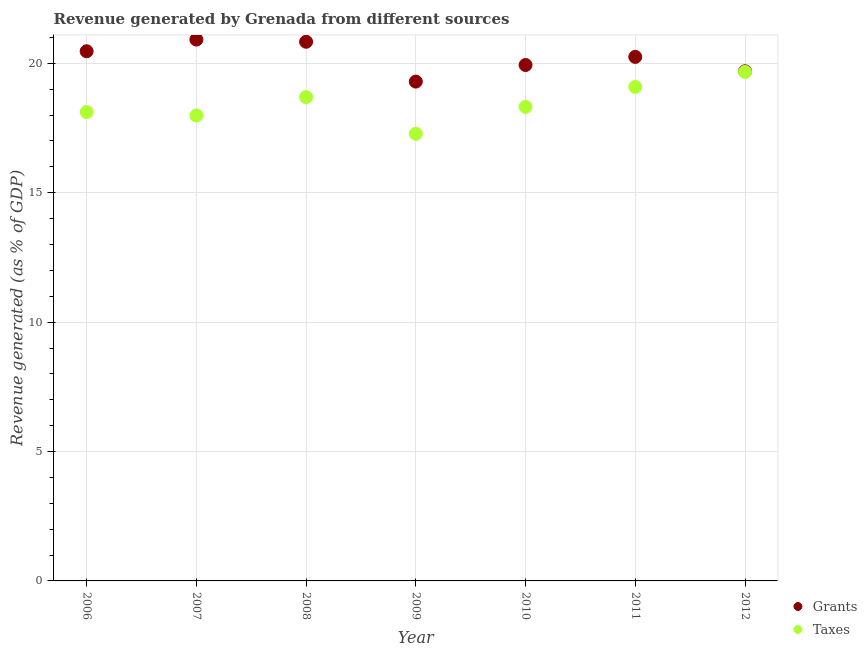Is the number of dotlines equal to the number of legend labels?
Provide a succinct answer. Yes. What is the revenue generated by grants in 2006?
Offer a very short reply. 20.47. Across all years, what is the maximum revenue generated by grants?
Provide a short and direct response. 20.92. Across all years, what is the minimum revenue generated by taxes?
Offer a terse response. 17.28. What is the total revenue generated by taxes in the graph?
Your response must be concise. 129.15. What is the difference between the revenue generated by taxes in 2010 and that in 2011?
Offer a terse response. -0.77. What is the difference between the revenue generated by grants in 2011 and the revenue generated by taxes in 2006?
Keep it short and to the point. 2.13. What is the average revenue generated by grants per year?
Your answer should be compact. 20.2. In the year 2012, what is the difference between the revenue generated by grants and revenue generated by taxes?
Give a very brief answer. 0.02. What is the ratio of the revenue generated by taxes in 2007 to that in 2012?
Ensure brevity in your answer.  0.91. Is the difference between the revenue generated by taxes in 2009 and 2011 greater than the difference between the revenue generated by grants in 2009 and 2011?
Your answer should be compact. No. What is the difference between the highest and the second highest revenue generated by taxes?
Provide a short and direct response. 0.58. What is the difference between the highest and the lowest revenue generated by grants?
Ensure brevity in your answer.  1.62. Does the revenue generated by taxes monotonically increase over the years?
Your answer should be compact. No. How many dotlines are there?
Your answer should be compact. 2. How many years are there in the graph?
Offer a very short reply. 7. Does the graph contain any zero values?
Your answer should be compact. No. How are the legend labels stacked?
Provide a succinct answer. Vertical. What is the title of the graph?
Offer a terse response. Revenue generated by Grenada from different sources. Does "Secondary" appear as one of the legend labels in the graph?
Provide a succinct answer. No. What is the label or title of the X-axis?
Keep it short and to the point. Year. What is the label or title of the Y-axis?
Provide a short and direct response. Revenue generated (as % of GDP). What is the Revenue generated (as % of GDP) in Grants in 2006?
Give a very brief answer. 20.47. What is the Revenue generated (as % of GDP) in Taxes in 2006?
Your answer should be very brief. 18.12. What is the Revenue generated (as % of GDP) in Grants in 2007?
Your answer should be compact. 20.92. What is the Revenue generated (as % of GDP) of Taxes in 2007?
Give a very brief answer. 17.99. What is the Revenue generated (as % of GDP) of Grants in 2008?
Offer a terse response. 20.83. What is the Revenue generated (as % of GDP) in Taxes in 2008?
Keep it short and to the point. 18.69. What is the Revenue generated (as % of GDP) of Grants in 2009?
Make the answer very short. 19.29. What is the Revenue generated (as % of GDP) in Taxes in 2009?
Your answer should be compact. 17.28. What is the Revenue generated (as % of GDP) of Grants in 2010?
Your response must be concise. 19.94. What is the Revenue generated (as % of GDP) in Taxes in 2010?
Your answer should be very brief. 18.32. What is the Revenue generated (as % of GDP) in Grants in 2011?
Provide a short and direct response. 20.25. What is the Revenue generated (as % of GDP) in Taxes in 2011?
Make the answer very short. 19.09. What is the Revenue generated (as % of GDP) in Grants in 2012?
Offer a very short reply. 19.69. What is the Revenue generated (as % of GDP) of Taxes in 2012?
Make the answer very short. 19.67. Across all years, what is the maximum Revenue generated (as % of GDP) in Grants?
Keep it short and to the point. 20.92. Across all years, what is the maximum Revenue generated (as % of GDP) in Taxes?
Offer a very short reply. 19.67. Across all years, what is the minimum Revenue generated (as % of GDP) in Grants?
Provide a succinct answer. 19.29. Across all years, what is the minimum Revenue generated (as % of GDP) of Taxes?
Offer a very short reply. 17.28. What is the total Revenue generated (as % of GDP) of Grants in the graph?
Your answer should be very brief. 141.39. What is the total Revenue generated (as % of GDP) of Taxes in the graph?
Your answer should be compact. 129.15. What is the difference between the Revenue generated (as % of GDP) in Grants in 2006 and that in 2007?
Your response must be concise. -0.45. What is the difference between the Revenue generated (as % of GDP) of Taxes in 2006 and that in 2007?
Offer a very short reply. 0.13. What is the difference between the Revenue generated (as % of GDP) of Grants in 2006 and that in 2008?
Offer a terse response. -0.37. What is the difference between the Revenue generated (as % of GDP) of Taxes in 2006 and that in 2008?
Your answer should be compact. -0.57. What is the difference between the Revenue generated (as % of GDP) in Grants in 2006 and that in 2009?
Provide a short and direct response. 1.17. What is the difference between the Revenue generated (as % of GDP) in Taxes in 2006 and that in 2009?
Your response must be concise. 0.84. What is the difference between the Revenue generated (as % of GDP) in Grants in 2006 and that in 2010?
Your answer should be compact. 0.53. What is the difference between the Revenue generated (as % of GDP) of Taxes in 2006 and that in 2010?
Your response must be concise. -0.2. What is the difference between the Revenue generated (as % of GDP) in Grants in 2006 and that in 2011?
Keep it short and to the point. 0.22. What is the difference between the Revenue generated (as % of GDP) in Taxes in 2006 and that in 2011?
Offer a terse response. -0.97. What is the difference between the Revenue generated (as % of GDP) of Grants in 2006 and that in 2012?
Offer a very short reply. 0.77. What is the difference between the Revenue generated (as % of GDP) of Taxes in 2006 and that in 2012?
Offer a terse response. -1.55. What is the difference between the Revenue generated (as % of GDP) in Grants in 2007 and that in 2008?
Make the answer very short. 0.08. What is the difference between the Revenue generated (as % of GDP) in Taxes in 2007 and that in 2008?
Your response must be concise. -0.71. What is the difference between the Revenue generated (as % of GDP) in Grants in 2007 and that in 2009?
Your answer should be compact. 1.62. What is the difference between the Revenue generated (as % of GDP) in Taxes in 2007 and that in 2009?
Provide a succinct answer. 0.71. What is the difference between the Revenue generated (as % of GDP) of Grants in 2007 and that in 2010?
Provide a succinct answer. 0.98. What is the difference between the Revenue generated (as % of GDP) in Taxes in 2007 and that in 2010?
Ensure brevity in your answer.  -0.33. What is the difference between the Revenue generated (as % of GDP) of Grants in 2007 and that in 2011?
Offer a very short reply. 0.67. What is the difference between the Revenue generated (as % of GDP) of Taxes in 2007 and that in 2011?
Your answer should be compact. -1.1. What is the difference between the Revenue generated (as % of GDP) in Grants in 2007 and that in 2012?
Ensure brevity in your answer.  1.23. What is the difference between the Revenue generated (as % of GDP) of Taxes in 2007 and that in 2012?
Keep it short and to the point. -1.68. What is the difference between the Revenue generated (as % of GDP) in Grants in 2008 and that in 2009?
Your answer should be compact. 1.54. What is the difference between the Revenue generated (as % of GDP) in Taxes in 2008 and that in 2009?
Ensure brevity in your answer.  1.41. What is the difference between the Revenue generated (as % of GDP) of Grants in 2008 and that in 2010?
Keep it short and to the point. 0.9. What is the difference between the Revenue generated (as % of GDP) in Taxes in 2008 and that in 2010?
Provide a succinct answer. 0.38. What is the difference between the Revenue generated (as % of GDP) in Grants in 2008 and that in 2011?
Keep it short and to the point. 0.59. What is the difference between the Revenue generated (as % of GDP) of Taxes in 2008 and that in 2011?
Give a very brief answer. -0.39. What is the difference between the Revenue generated (as % of GDP) in Grants in 2008 and that in 2012?
Provide a short and direct response. 1.14. What is the difference between the Revenue generated (as % of GDP) of Taxes in 2008 and that in 2012?
Provide a succinct answer. -0.97. What is the difference between the Revenue generated (as % of GDP) of Grants in 2009 and that in 2010?
Ensure brevity in your answer.  -0.64. What is the difference between the Revenue generated (as % of GDP) in Taxes in 2009 and that in 2010?
Provide a succinct answer. -1.04. What is the difference between the Revenue generated (as % of GDP) in Grants in 2009 and that in 2011?
Give a very brief answer. -0.95. What is the difference between the Revenue generated (as % of GDP) in Taxes in 2009 and that in 2011?
Your response must be concise. -1.81. What is the difference between the Revenue generated (as % of GDP) of Grants in 2009 and that in 2012?
Your response must be concise. -0.4. What is the difference between the Revenue generated (as % of GDP) of Taxes in 2009 and that in 2012?
Provide a short and direct response. -2.39. What is the difference between the Revenue generated (as % of GDP) in Grants in 2010 and that in 2011?
Keep it short and to the point. -0.31. What is the difference between the Revenue generated (as % of GDP) of Taxes in 2010 and that in 2011?
Your response must be concise. -0.77. What is the difference between the Revenue generated (as % of GDP) in Grants in 2010 and that in 2012?
Your answer should be compact. 0.24. What is the difference between the Revenue generated (as % of GDP) of Taxes in 2010 and that in 2012?
Your response must be concise. -1.35. What is the difference between the Revenue generated (as % of GDP) of Grants in 2011 and that in 2012?
Provide a succinct answer. 0.56. What is the difference between the Revenue generated (as % of GDP) of Taxes in 2011 and that in 2012?
Your response must be concise. -0.58. What is the difference between the Revenue generated (as % of GDP) of Grants in 2006 and the Revenue generated (as % of GDP) of Taxes in 2007?
Make the answer very short. 2.48. What is the difference between the Revenue generated (as % of GDP) of Grants in 2006 and the Revenue generated (as % of GDP) of Taxes in 2008?
Your answer should be compact. 1.77. What is the difference between the Revenue generated (as % of GDP) in Grants in 2006 and the Revenue generated (as % of GDP) in Taxes in 2009?
Ensure brevity in your answer.  3.19. What is the difference between the Revenue generated (as % of GDP) in Grants in 2006 and the Revenue generated (as % of GDP) in Taxes in 2010?
Your response must be concise. 2.15. What is the difference between the Revenue generated (as % of GDP) in Grants in 2006 and the Revenue generated (as % of GDP) in Taxes in 2011?
Ensure brevity in your answer.  1.38. What is the difference between the Revenue generated (as % of GDP) in Grants in 2006 and the Revenue generated (as % of GDP) in Taxes in 2012?
Offer a terse response. 0.8. What is the difference between the Revenue generated (as % of GDP) in Grants in 2007 and the Revenue generated (as % of GDP) in Taxes in 2008?
Keep it short and to the point. 2.22. What is the difference between the Revenue generated (as % of GDP) of Grants in 2007 and the Revenue generated (as % of GDP) of Taxes in 2009?
Your answer should be very brief. 3.64. What is the difference between the Revenue generated (as % of GDP) in Grants in 2007 and the Revenue generated (as % of GDP) in Taxes in 2010?
Offer a very short reply. 2.6. What is the difference between the Revenue generated (as % of GDP) of Grants in 2007 and the Revenue generated (as % of GDP) of Taxes in 2011?
Your answer should be compact. 1.83. What is the difference between the Revenue generated (as % of GDP) of Grants in 2008 and the Revenue generated (as % of GDP) of Taxes in 2009?
Your answer should be compact. 3.56. What is the difference between the Revenue generated (as % of GDP) in Grants in 2008 and the Revenue generated (as % of GDP) in Taxes in 2010?
Provide a short and direct response. 2.52. What is the difference between the Revenue generated (as % of GDP) of Grants in 2008 and the Revenue generated (as % of GDP) of Taxes in 2011?
Offer a terse response. 1.75. What is the difference between the Revenue generated (as % of GDP) of Grants in 2008 and the Revenue generated (as % of GDP) of Taxes in 2012?
Provide a short and direct response. 1.17. What is the difference between the Revenue generated (as % of GDP) of Grants in 2009 and the Revenue generated (as % of GDP) of Taxes in 2010?
Your response must be concise. 0.98. What is the difference between the Revenue generated (as % of GDP) of Grants in 2009 and the Revenue generated (as % of GDP) of Taxes in 2011?
Offer a terse response. 0.21. What is the difference between the Revenue generated (as % of GDP) in Grants in 2009 and the Revenue generated (as % of GDP) in Taxes in 2012?
Ensure brevity in your answer.  -0.37. What is the difference between the Revenue generated (as % of GDP) in Grants in 2010 and the Revenue generated (as % of GDP) in Taxes in 2011?
Offer a terse response. 0.85. What is the difference between the Revenue generated (as % of GDP) in Grants in 2010 and the Revenue generated (as % of GDP) in Taxes in 2012?
Keep it short and to the point. 0.27. What is the difference between the Revenue generated (as % of GDP) of Grants in 2011 and the Revenue generated (as % of GDP) of Taxes in 2012?
Offer a terse response. 0.58. What is the average Revenue generated (as % of GDP) in Grants per year?
Your response must be concise. 20.2. What is the average Revenue generated (as % of GDP) of Taxes per year?
Provide a succinct answer. 18.45. In the year 2006, what is the difference between the Revenue generated (as % of GDP) of Grants and Revenue generated (as % of GDP) of Taxes?
Provide a short and direct response. 2.35. In the year 2007, what is the difference between the Revenue generated (as % of GDP) of Grants and Revenue generated (as % of GDP) of Taxes?
Offer a very short reply. 2.93. In the year 2008, what is the difference between the Revenue generated (as % of GDP) of Grants and Revenue generated (as % of GDP) of Taxes?
Your answer should be very brief. 2.14. In the year 2009, what is the difference between the Revenue generated (as % of GDP) in Grants and Revenue generated (as % of GDP) in Taxes?
Provide a succinct answer. 2.02. In the year 2010, what is the difference between the Revenue generated (as % of GDP) of Grants and Revenue generated (as % of GDP) of Taxes?
Your response must be concise. 1.62. In the year 2011, what is the difference between the Revenue generated (as % of GDP) in Grants and Revenue generated (as % of GDP) in Taxes?
Provide a short and direct response. 1.16. In the year 2012, what is the difference between the Revenue generated (as % of GDP) of Grants and Revenue generated (as % of GDP) of Taxes?
Offer a terse response. 0.02. What is the ratio of the Revenue generated (as % of GDP) of Grants in 2006 to that in 2007?
Provide a short and direct response. 0.98. What is the ratio of the Revenue generated (as % of GDP) in Taxes in 2006 to that in 2007?
Provide a short and direct response. 1.01. What is the ratio of the Revenue generated (as % of GDP) in Grants in 2006 to that in 2008?
Ensure brevity in your answer.  0.98. What is the ratio of the Revenue generated (as % of GDP) in Taxes in 2006 to that in 2008?
Offer a terse response. 0.97. What is the ratio of the Revenue generated (as % of GDP) of Grants in 2006 to that in 2009?
Provide a short and direct response. 1.06. What is the ratio of the Revenue generated (as % of GDP) in Taxes in 2006 to that in 2009?
Give a very brief answer. 1.05. What is the ratio of the Revenue generated (as % of GDP) in Grants in 2006 to that in 2010?
Provide a short and direct response. 1.03. What is the ratio of the Revenue generated (as % of GDP) in Taxes in 2006 to that in 2010?
Offer a very short reply. 0.99. What is the ratio of the Revenue generated (as % of GDP) in Grants in 2006 to that in 2011?
Provide a succinct answer. 1.01. What is the ratio of the Revenue generated (as % of GDP) in Taxes in 2006 to that in 2011?
Keep it short and to the point. 0.95. What is the ratio of the Revenue generated (as % of GDP) in Grants in 2006 to that in 2012?
Offer a terse response. 1.04. What is the ratio of the Revenue generated (as % of GDP) of Taxes in 2006 to that in 2012?
Make the answer very short. 0.92. What is the ratio of the Revenue generated (as % of GDP) of Taxes in 2007 to that in 2008?
Keep it short and to the point. 0.96. What is the ratio of the Revenue generated (as % of GDP) in Grants in 2007 to that in 2009?
Provide a succinct answer. 1.08. What is the ratio of the Revenue generated (as % of GDP) of Taxes in 2007 to that in 2009?
Your answer should be very brief. 1.04. What is the ratio of the Revenue generated (as % of GDP) in Grants in 2007 to that in 2010?
Provide a short and direct response. 1.05. What is the ratio of the Revenue generated (as % of GDP) in Taxes in 2007 to that in 2010?
Give a very brief answer. 0.98. What is the ratio of the Revenue generated (as % of GDP) of Grants in 2007 to that in 2011?
Offer a very short reply. 1.03. What is the ratio of the Revenue generated (as % of GDP) in Taxes in 2007 to that in 2011?
Provide a succinct answer. 0.94. What is the ratio of the Revenue generated (as % of GDP) in Grants in 2007 to that in 2012?
Provide a succinct answer. 1.06. What is the ratio of the Revenue generated (as % of GDP) of Taxes in 2007 to that in 2012?
Make the answer very short. 0.91. What is the ratio of the Revenue generated (as % of GDP) of Grants in 2008 to that in 2009?
Your answer should be compact. 1.08. What is the ratio of the Revenue generated (as % of GDP) in Taxes in 2008 to that in 2009?
Your answer should be compact. 1.08. What is the ratio of the Revenue generated (as % of GDP) of Grants in 2008 to that in 2010?
Make the answer very short. 1.05. What is the ratio of the Revenue generated (as % of GDP) of Taxes in 2008 to that in 2010?
Offer a terse response. 1.02. What is the ratio of the Revenue generated (as % of GDP) of Grants in 2008 to that in 2011?
Ensure brevity in your answer.  1.03. What is the ratio of the Revenue generated (as % of GDP) of Taxes in 2008 to that in 2011?
Offer a terse response. 0.98. What is the ratio of the Revenue generated (as % of GDP) in Grants in 2008 to that in 2012?
Your response must be concise. 1.06. What is the ratio of the Revenue generated (as % of GDP) of Taxes in 2008 to that in 2012?
Ensure brevity in your answer.  0.95. What is the ratio of the Revenue generated (as % of GDP) in Grants in 2009 to that in 2010?
Offer a very short reply. 0.97. What is the ratio of the Revenue generated (as % of GDP) of Taxes in 2009 to that in 2010?
Give a very brief answer. 0.94. What is the ratio of the Revenue generated (as % of GDP) of Grants in 2009 to that in 2011?
Your response must be concise. 0.95. What is the ratio of the Revenue generated (as % of GDP) of Taxes in 2009 to that in 2011?
Provide a succinct answer. 0.91. What is the ratio of the Revenue generated (as % of GDP) of Grants in 2009 to that in 2012?
Give a very brief answer. 0.98. What is the ratio of the Revenue generated (as % of GDP) of Taxes in 2009 to that in 2012?
Make the answer very short. 0.88. What is the ratio of the Revenue generated (as % of GDP) in Grants in 2010 to that in 2011?
Make the answer very short. 0.98. What is the ratio of the Revenue generated (as % of GDP) of Taxes in 2010 to that in 2011?
Offer a very short reply. 0.96. What is the ratio of the Revenue generated (as % of GDP) in Grants in 2010 to that in 2012?
Give a very brief answer. 1.01. What is the ratio of the Revenue generated (as % of GDP) of Taxes in 2010 to that in 2012?
Keep it short and to the point. 0.93. What is the ratio of the Revenue generated (as % of GDP) in Grants in 2011 to that in 2012?
Your response must be concise. 1.03. What is the ratio of the Revenue generated (as % of GDP) in Taxes in 2011 to that in 2012?
Provide a succinct answer. 0.97. What is the difference between the highest and the second highest Revenue generated (as % of GDP) of Grants?
Provide a succinct answer. 0.08. What is the difference between the highest and the second highest Revenue generated (as % of GDP) in Taxes?
Your answer should be compact. 0.58. What is the difference between the highest and the lowest Revenue generated (as % of GDP) of Grants?
Provide a succinct answer. 1.62. What is the difference between the highest and the lowest Revenue generated (as % of GDP) of Taxes?
Ensure brevity in your answer.  2.39. 